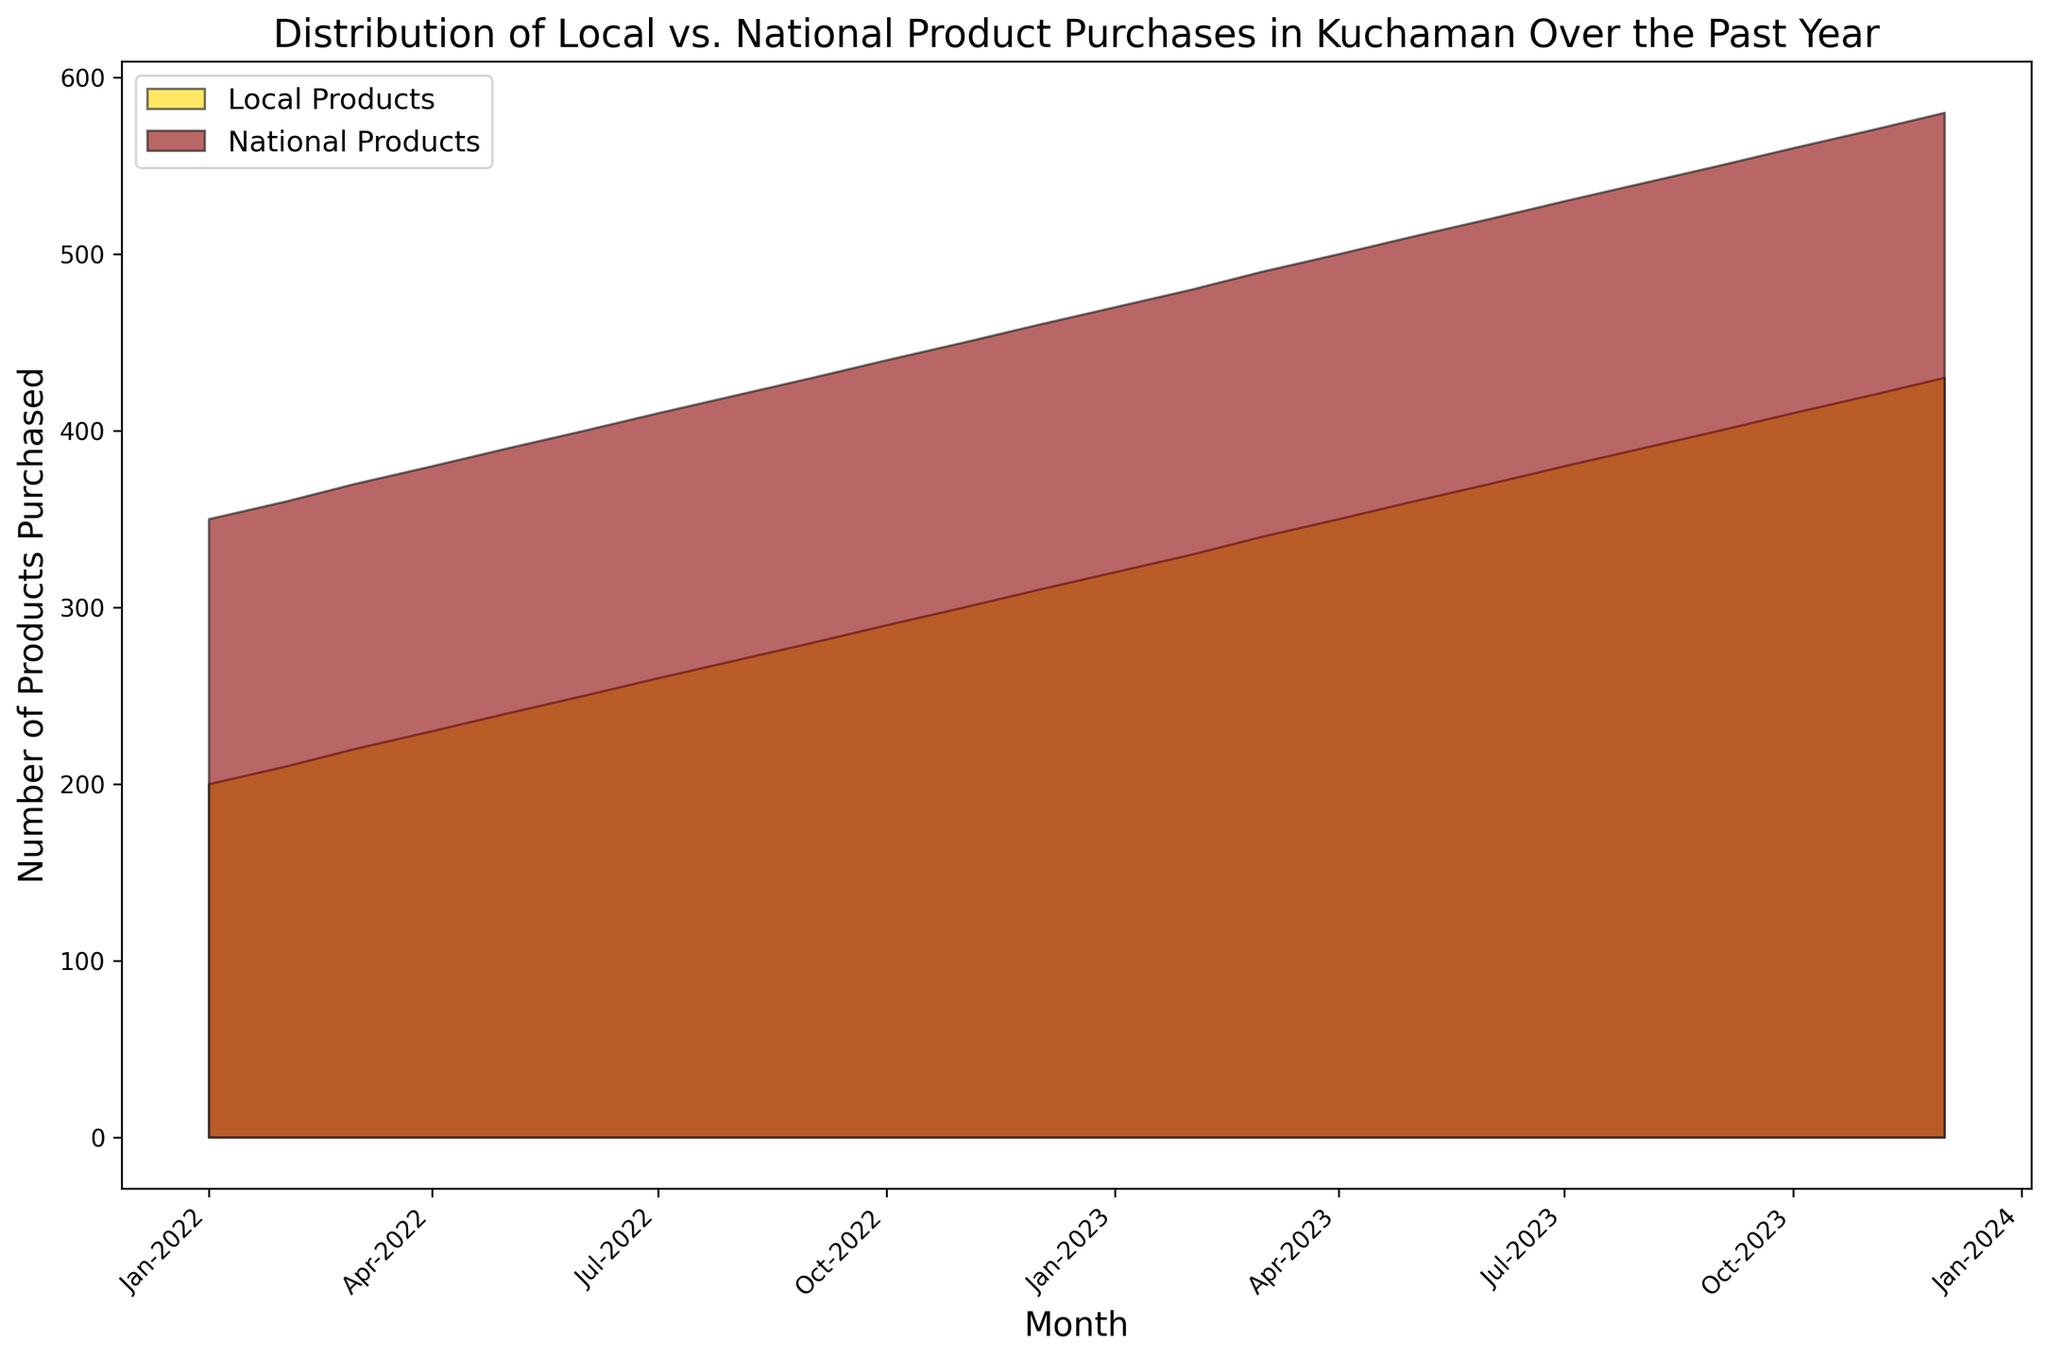What trend can you observe in local product purchases from January to December 2023? The local product purchases have been steadily increasing each month from 320 in January 2023 to 430 in December 2023. This shows a consistent upward trend.
Answer: An increasing trend Which month had the highest number of national product purchases? By examining the highest point on the red area segment, December 2023 had the highest number of national product purchases at 580.
Answer: December 2023 What is the difference in the number of local products purchased between January 2022 and January 2023? In January 2022, there were 200 local products purchased, and in January 2023, there were 320. The difference is 320 - 200 = 120.
Answer: 120 Are there any months where the number of local product purchases is equal to the number of national product purchases? Observing the chart, there are no instances where the yellow area (local products) matches perfectly with the red area (national products) at any point in time.
Answer: No By how much did national product purchases increase from January 2022 to December 2023? National product purchases were 350 in January 2022 and increased to 580 by December 2023. The increase is 580 - 350 = 230.
Answer: 230 Did the month of May 2023 have more local or national product purchases? In May 2023, local products were at 360 and national products were at 510. Comparing these, national product purchases are higher.
Answer: National products If the rate of increase for local products continues, how many local products will be purchased in January 2024? The increase from December 2023 to January 2023 for local products is 10 each month, continuing this trend, by January 2024, it would be 430 + 10 = 440.
Answer: 440 What is the average number of national products purchased in the first quarter of 2023? The number of national products purchased in the first quarter (January, February, March 2023) are 470, 480, and 490 respectively. The average is (470 + 480 + 490) / 3 = 480.
Answer: 480 How do the visual areas of local and national products compare throughout the year? The yellow area (local products) is consistently smaller than the red area (national products), showing that national product purchases are higher every month of the year.
Answer: National products are higher What month saw the beginning of a noticeable increase in local product purchases? Observing the chart, there's a noticeable acceleration in local product purchases starting around June 2023, where the gap between each month starts to broaden.
Answer: June 2023 